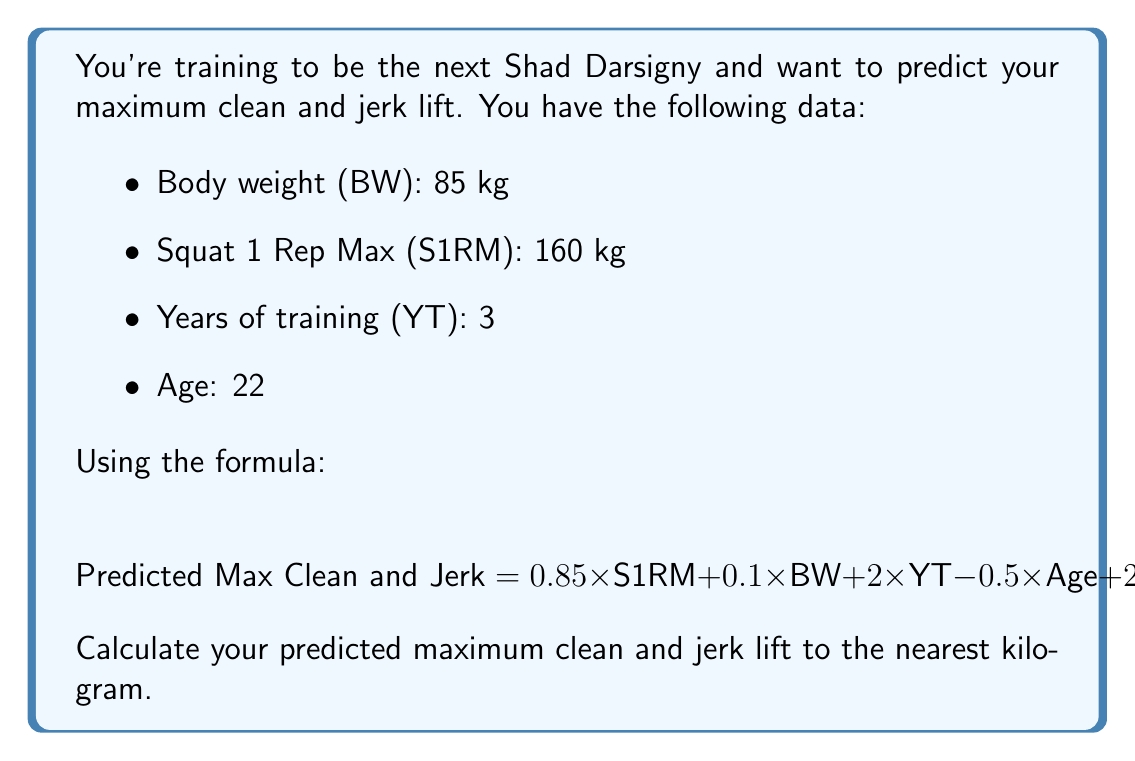Teach me how to tackle this problem. Let's break this down step-by-step:

1) First, let's identify our variables:
   - S1RM (Squat 1 Rep Max) = 160 kg
   - BW (Body Weight) = 85 kg
   - YT (Years of Training) = 3
   - Age = 22

2) Now, let's plug these values into our formula:

   $$\text{Predicted Max Clean and Jerk} = 0.85 \times S1RM + 0.1 \times BW + 2 \times YT - 0.5 \times \text{Age} + 20$$

3) Let's calculate each term:
   - $0.85 \times S1RM = 0.85 \times 160 = 136$
   - $0.1 \times BW = 0.1 \times 85 = 8.5$
   - $2 \times YT = 2 \times 3 = 6$
   - $0.5 \times \text{Age} = 0.5 \times 22 = 11$

4) Now, let's sum up all the terms:

   $$136 + 8.5 + 6 - 11 + 20 = 159.5$$

5) The question asks for the answer to the nearest kilogram, so we round 159.5 to 160.
Answer: 160 kg 